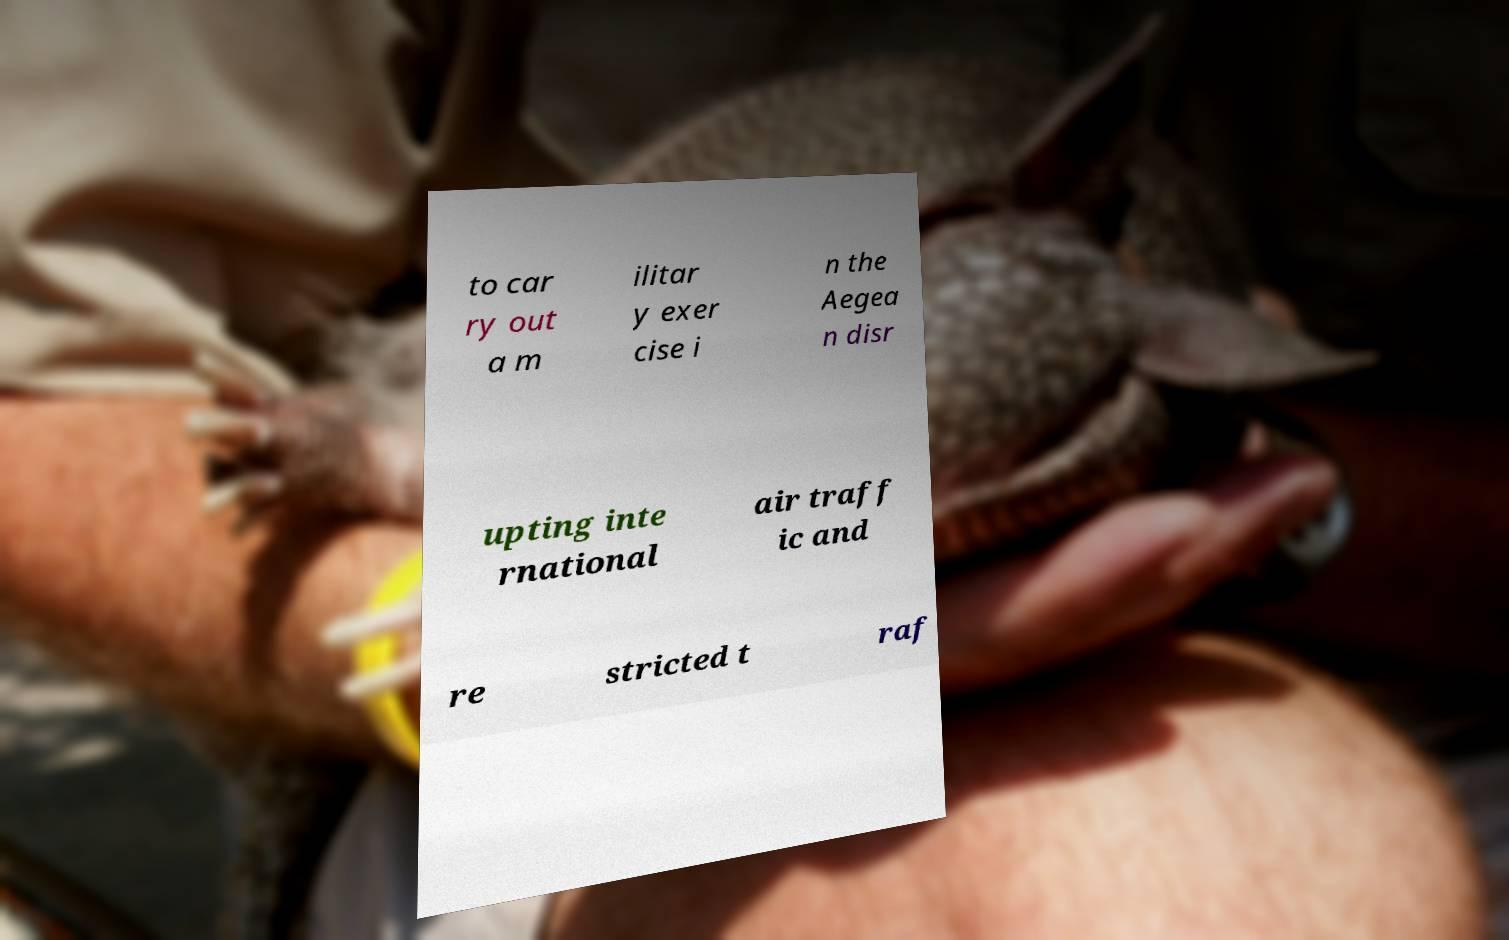Could you assist in decoding the text presented in this image and type it out clearly? to car ry out a m ilitar y exer cise i n the Aegea n disr upting inte rnational air traff ic and re stricted t raf 